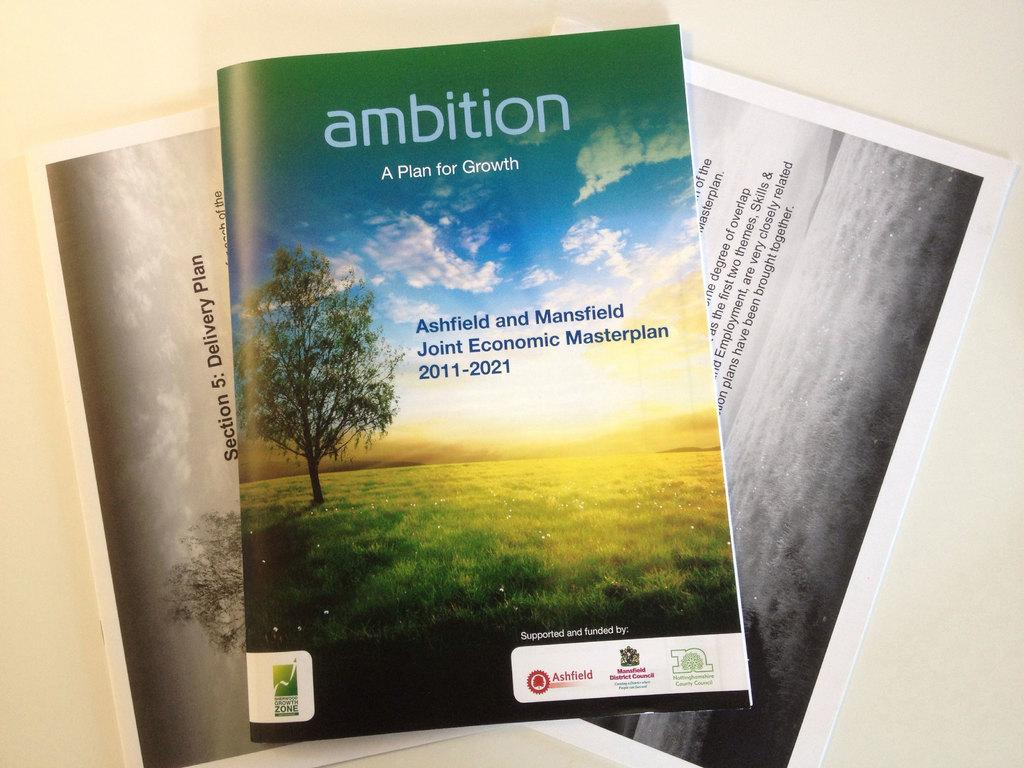<image>
Present a compact description of the photo's key features. A book called Ambition is about a plan for growth 